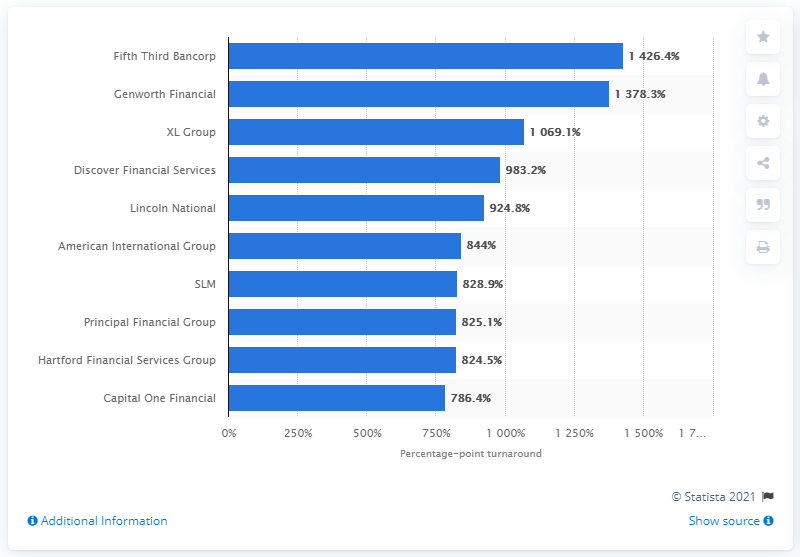List a handful of essential elements in this visual. During the period of October 9, 2007 to September 10, 2013, Fifth Third Bancorp experienced a significant turnaround, with a percentage point improvement. 